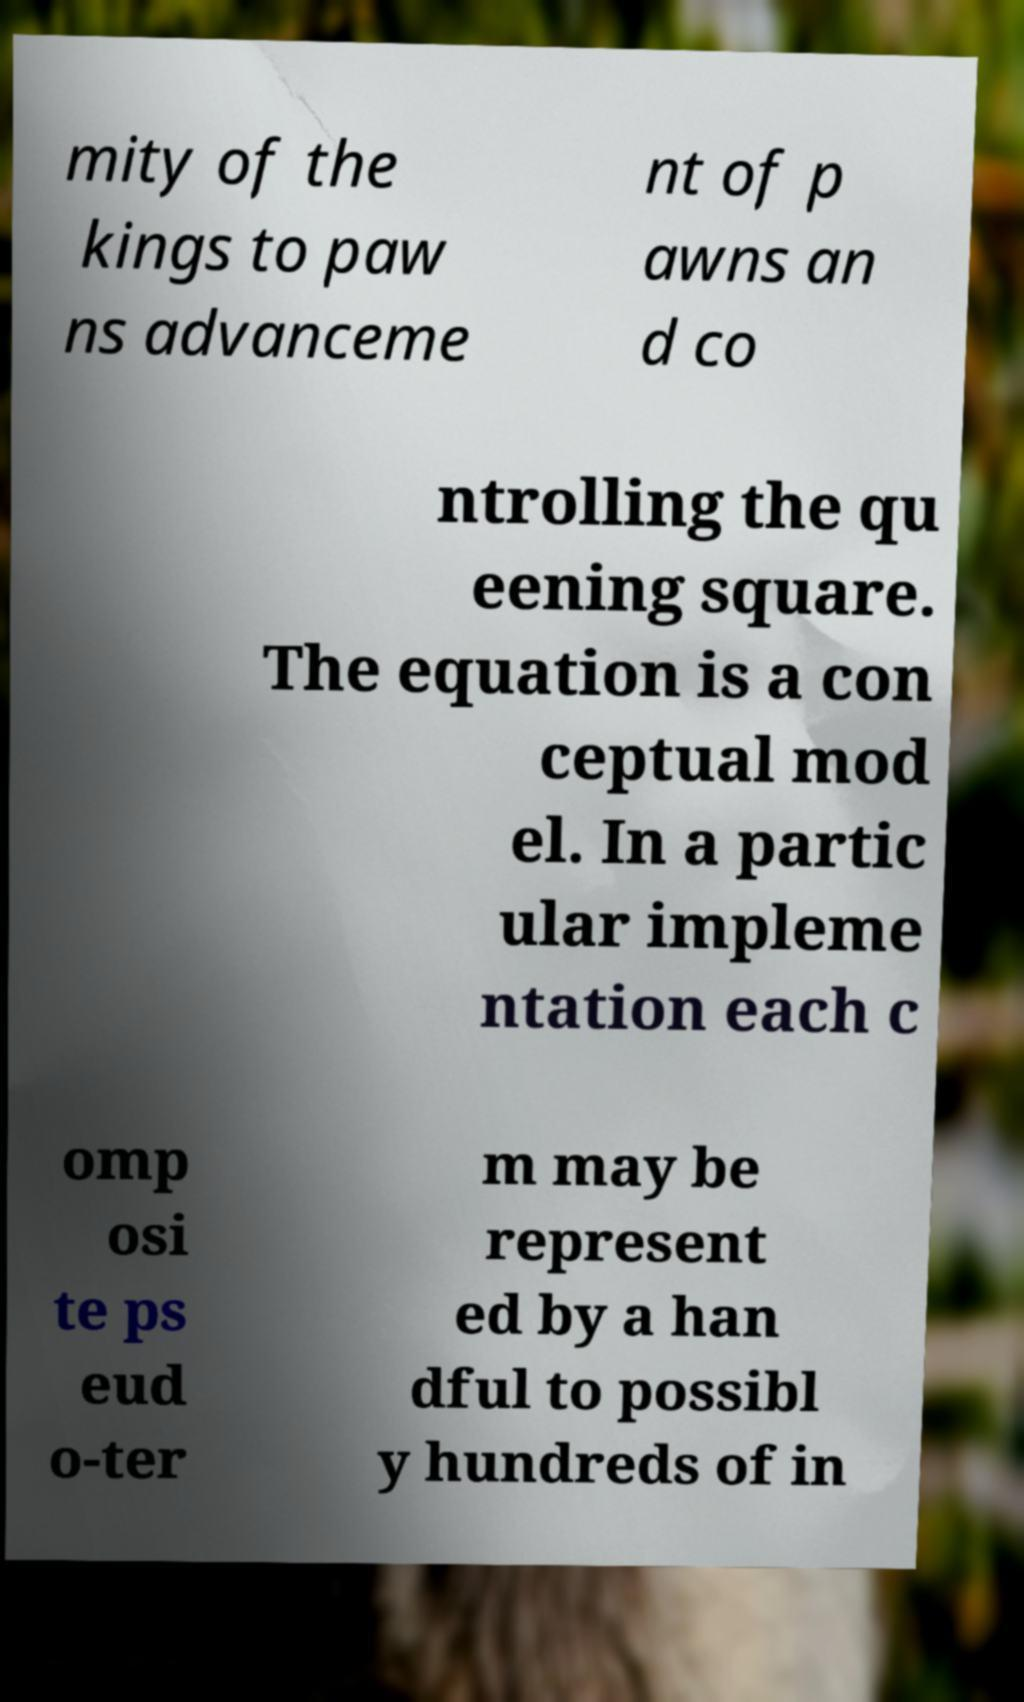There's text embedded in this image that I need extracted. Can you transcribe it verbatim? mity of the kings to paw ns advanceme nt of p awns an d co ntrolling the qu eening square. The equation is a con ceptual mod el. In a partic ular impleme ntation each c omp osi te ps eud o-ter m may be represent ed by a han dful to possibl y hundreds of in 